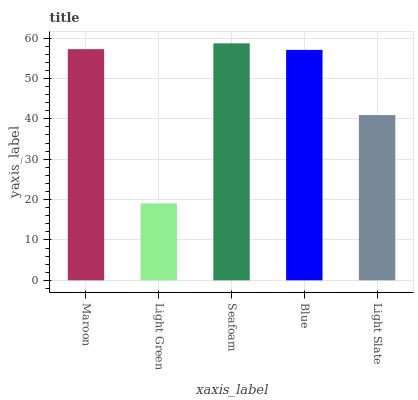Is Light Green the minimum?
Answer yes or no. Yes. Is Seafoam the maximum?
Answer yes or no. Yes. Is Seafoam the minimum?
Answer yes or no. No. Is Light Green the maximum?
Answer yes or no. No. Is Seafoam greater than Light Green?
Answer yes or no. Yes. Is Light Green less than Seafoam?
Answer yes or no. Yes. Is Light Green greater than Seafoam?
Answer yes or no. No. Is Seafoam less than Light Green?
Answer yes or no. No. Is Blue the high median?
Answer yes or no. Yes. Is Blue the low median?
Answer yes or no. Yes. Is Light Slate the high median?
Answer yes or no. No. Is Light Green the low median?
Answer yes or no. No. 